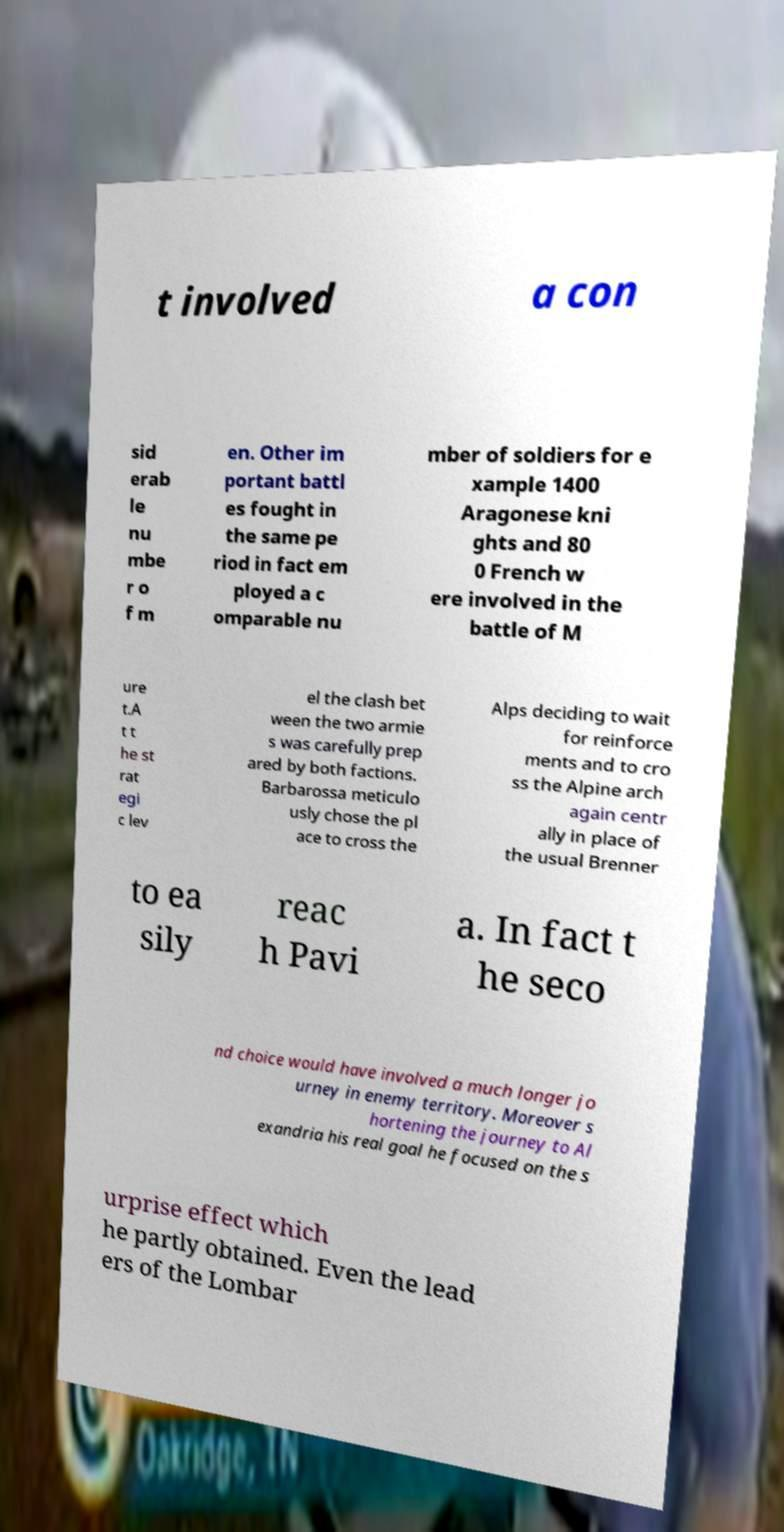What messages or text are displayed in this image? I need them in a readable, typed format. t involved a con sid erab le nu mbe r o f m en. Other im portant battl es fought in the same pe riod in fact em ployed a c omparable nu mber of soldiers for e xample 1400 Aragonese kni ghts and 80 0 French w ere involved in the battle of M ure t.A t t he st rat egi c lev el the clash bet ween the two armie s was carefully prep ared by both factions. Barbarossa meticulo usly chose the pl ace to cross the Alps deciding to wait for reinforce ments and to cro ss the Alpine arch again centr ally in place of the usual Brenner to ea sily reac h Pavi a. In fact t he seco nd choice would have involved a much longer jo urney in enemy territory. Moreover s hortening the journey to Al exandria his real goal he focused on the s urprise effect which he partly obtained. Even the lead ers of the Lombar 